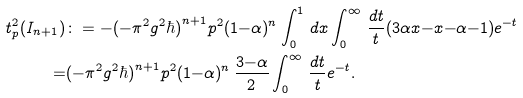<formula> <loc_0><loc_0><loc_500><loc_500>t ^ { 2 } _ { p } ( I _ { n + 1 } ) & \colon = - ( - \pi ^ { 2 } g ^ { 2 } \hbar { ) } ^ { n + 1 } p ^ { 2 } ( 1 { - } \alpha ) ^ { n } \int _ { 0 } ^ { 1 } \, d x \int _ { 0 } ^ { \infty } \, \frac { d t } { t } ( 3 \alpha x { - } x { - } \alpha { - } 1 ) e ^ { - t } \\ = & ( - \pi ^ { 2 } g ^ { 2 } \hbar { ) } ^ { n + 1 } p ^ { 2 } ( 1 { - } \alpha ) ^ { n } \, \frac { 3 { - } \alpha } { 2 } \int _ { 0 } ^ { \infty } \, \frac { d t } { t } e ^ { - t } .</formula> 